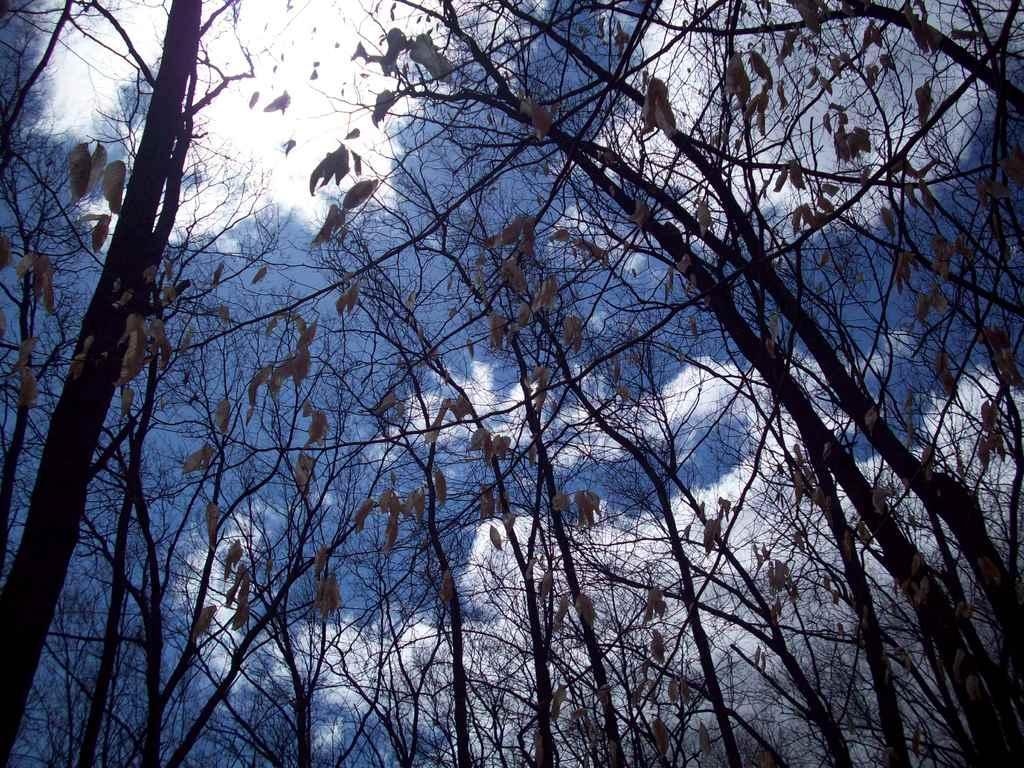How would you summarize this image in a sentence or two? In this image there are group of trees and in the background there is sky and clouds. 